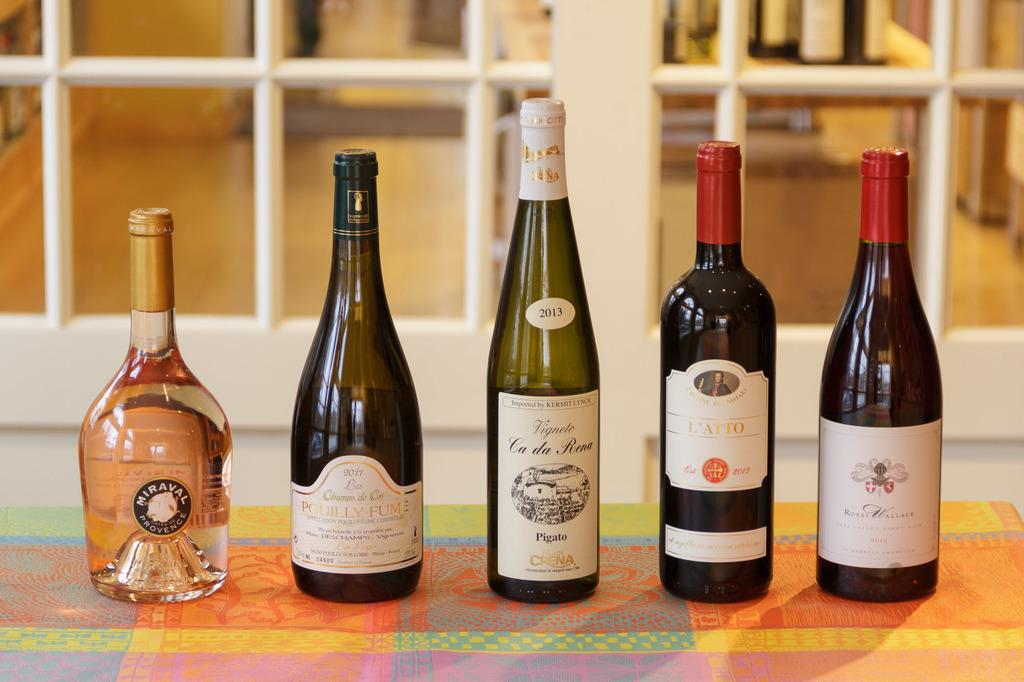What year is the bottle in the middle?
Your answer should be very brief. 2013. What kind of drink is the bottle second from the right?
Offer a very short reply. Wine. 